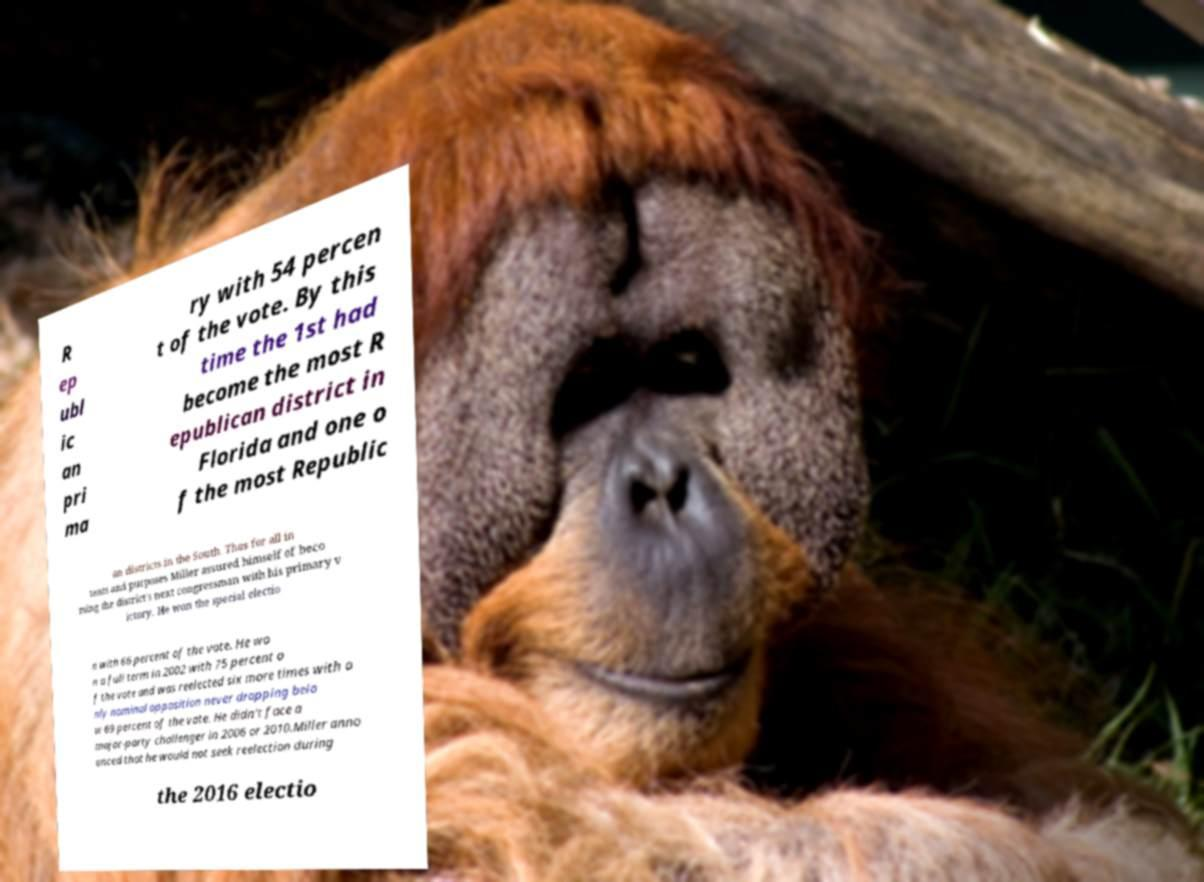Can you read and provide the text displayed in the image?This photo seems to have some interesting text. Can you extract and type it out for me? R ep ubl ic an pri ma ry with 54 percen t of the vote. By this time the 1st had become the most R epublican district in Florida and one o f the most Republic an districts in the South. Thus for all in tents and purposes Miller assured himself of beco ming the district's next congressman with his primary v ictory. He won the special electio n with 66 percent of the vote. He wo n a full term in 2002 with 75 percent o f the vote and was reelected six more times with o nly nominal opposition never dropping belo w 69 percent of the vote. He didn't face a major-party challenger in 2006 or 2010.Miller anno unced that he would not seek reelection during the 2016 electio 